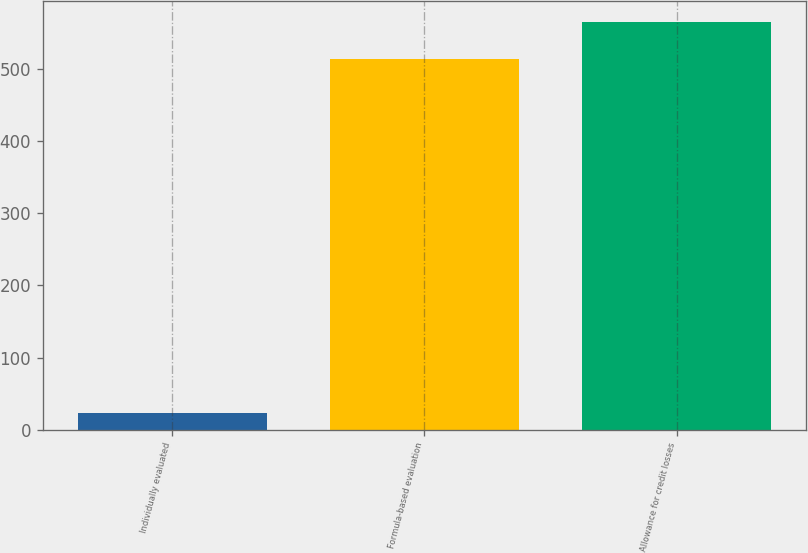Convert chart. <chart><loc_0><loc_0><loc_500><loc_500><bar_chart><fcel>Individually evaluated<fcel>Formula-based evaluation<fcel>Allowance for credit losses<nl><fcel>23<fcel>514<fcel>565.4<nl></chart> 